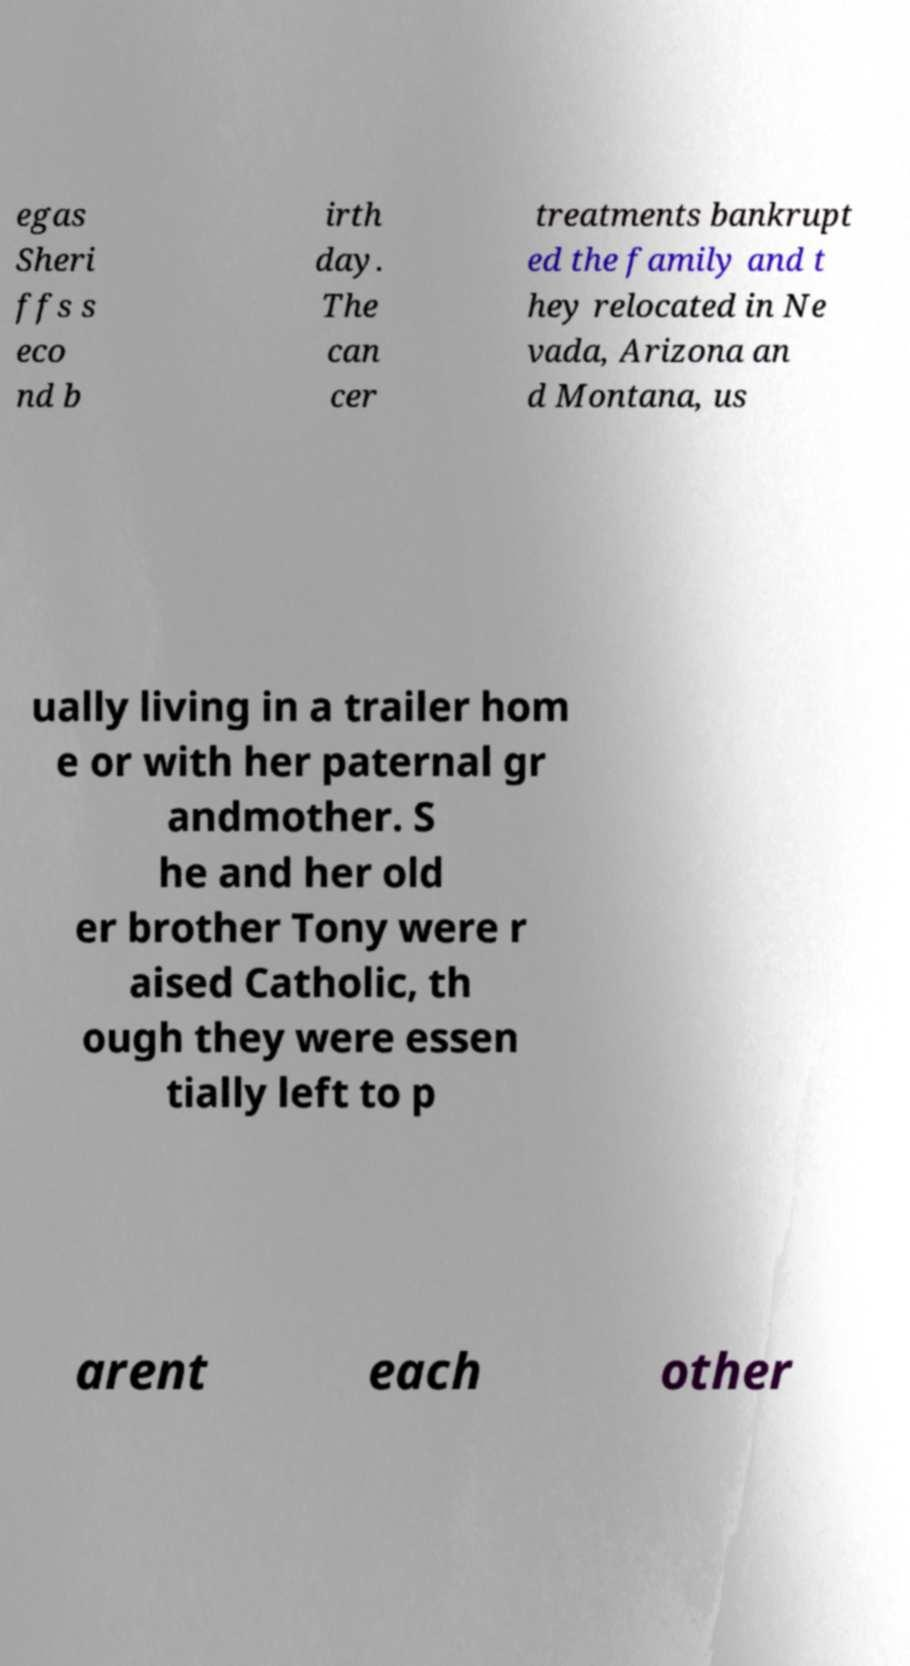Can you read and provide the text displayed in the image?This photo seems to have some interesting text. Can you extract and type it out for me? egas Sheri ffs s eco nd b irth day. The can cer treatments bankrupt ed the family and t hey relocated in Ne vada, Arizona an d Montana, us ually living in a trailer hom e or with her paternal gr andmother. S he and her old er brother Tony were r aised Catholic, th ough they were essen tially left to p arent each other 